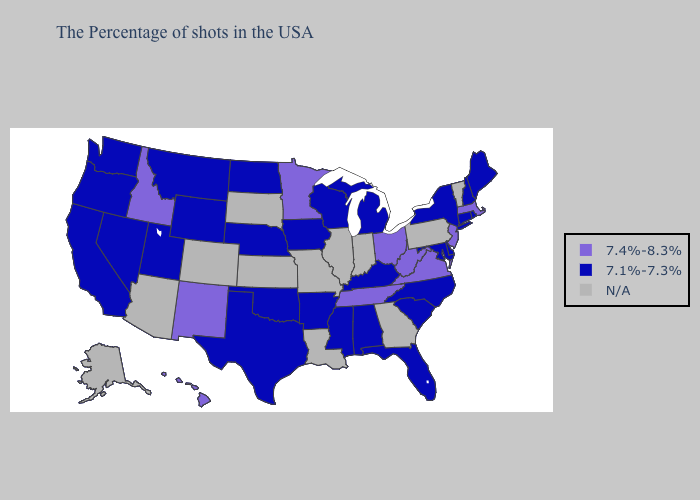Among the states that border Utah , which have the highest value?
Quick response, please. New Mexico, Idaho. Name the states that have a value in the range 7.4%-8.3%?
Concise answer only. Massachusetts, New Jersey, Virginia, West Virginia, Ohio, Tennessee, Minnesota, New Mexico, Idaho, Hawaii. Among the states that border Virginia , does West Virginia have the lowest value?
Short answer required. No. What is the highest value in the West ?
Concise answer only. 7.4%-8.3%. Name the states that have a value in the range 7.4%-8.3%?
Give a very brief answer. Massachusetts, New Jersey, Virginia, West Virginia, Ohio, Tennessee, Minnesota, New Mexico, Idaho, Hawaii. Does Oregon have the highest value in the West?
Quick response, please. No. Name the states that have a value in the range N/A?
Be succinct. Vermont, Pennsylvania, Georgia, Indiana, Illinois, Louisiana, Missouri, Kansas, South Dakota, Colorado, Arizona, Alaska. What is the value of New Hampshire?
Quick response, please. 7.1%-7.3%. What is the highest value in the MidWest ?
Quick response, please. 7.4%-8.3%. Name the states that have a value in the range 7.1%-7.3%?
Short answer required. Maine, Rhode Island, New Hampshire, Connecticut, New York, Delaware, Maryland, North Carolina, South Carolina, Florida, Michigan, Kentucky, Alabama, Wisconsin, Mississippi, Arkansas, Iowa, Nebraska, Oklahoma, Texas, North Dakota, Wyoming, Utah, Montana, Nevada, California, Washington, Oregon. What is the highest value in the USA?
Concise answer only. 7.4%-8.3%. What is the lowest value in the South?
Quick response, please. 7.1%-7.3%. Does the first symbol in the legend represent the smallest category?
Concise answer only. No. What is the highest value in the Northeast ?
Short answer required. 7.4%-8.3%. Among the states that border Idaho , which have the highest value?
Concise answer only. Wyoming, Utah, Montana, Nevada, Washington, Oregon. 